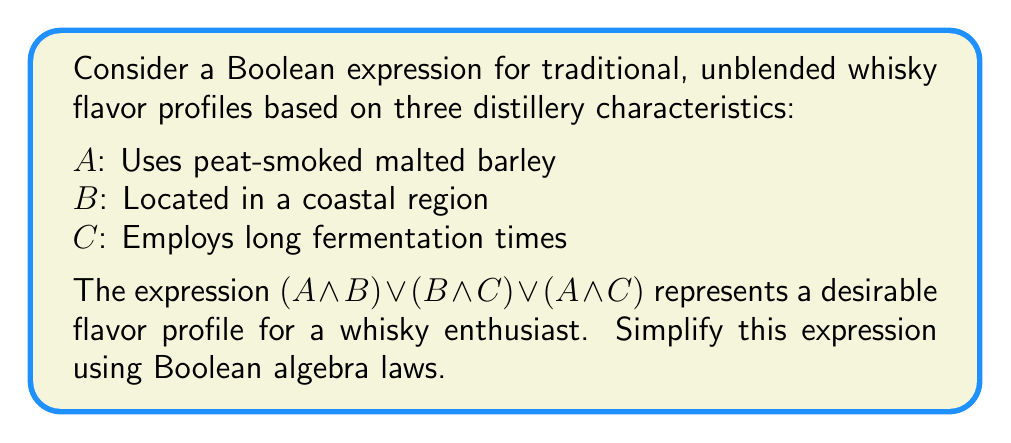Solve this math problem. Let's simplify the expression $(A \land B) \lor (B \land C) \lor (A \land C)$ step by step:

1) First, we can apply the distributive law to factor out $B$ from the first two terms:
   $$(A \land B) \lor (B \land C) \lor (A \land C) = B \land (A \lor C) \lor (A \land C)$$

2) Now, we can apply the distributive law again to the entire expression:
   $$B \land (A \lor C) \lor (A \land C) = (B \lor A) \land (B \lor C) \land (A \lor C)$$

3) We can rearrange the terms using the commutative law:
   $$(A \lor B) \land (B \lor C) \land (A \lor C)$$

4) This expression is in the form of a conjunction of disjunctions, which is already in its simplest form. It's known as the canonical conjunctive normal form (CNF).

5) Interpreting this result: A whisky with a desirable flavor profile will have at least two of the three characteristics: peat-smoked malted barley, coastal location, or long fermentation times.
Answer: $(A \lor B) \land (B \lor C) \land (A \lor C)$ 